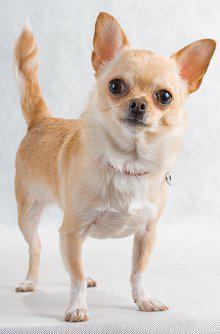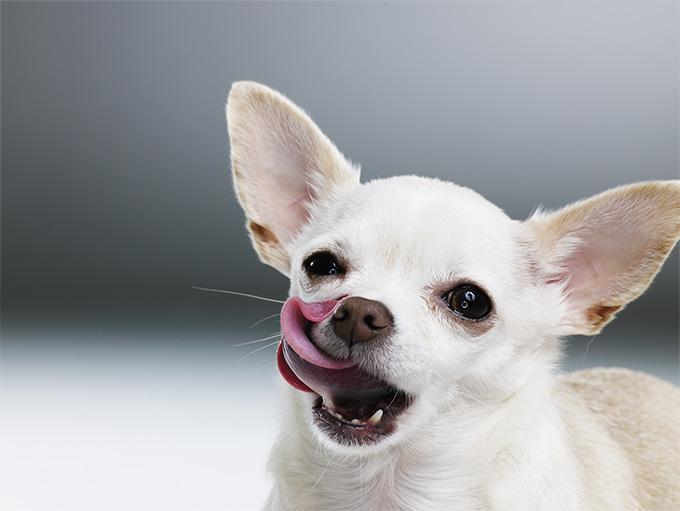The first image is the image on the left, the second image is the image on the right. For the images displayed, is the sentence "the dog on the right image has its mouth open" factually correct? Answer yes or no. Yes. 